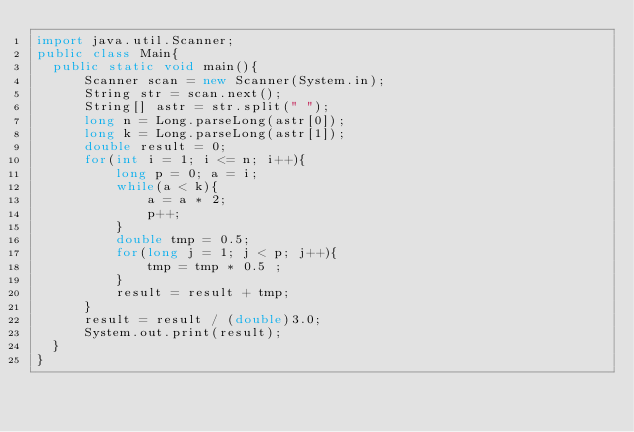Convert code to text. <code><loc_0><loc_0><loc_500><loc_500><_Java_>import java.util.Scanner;
public class Main{
  public static void main(){
      Scanner scan = new Scanner(System.in);
      String str = scan.next();
      String[] astr = str.split(" ");
      long n = Long.parseLong(astr[0]);
      long k = Long.parseLong(astr[1]);
      double result = 0;
      for(int i = 1; i <= n; i++){
          long p = 0; a = i;	
          while(a < k){
              a = a * 2;
              p++;
          }
          double tmp = 0.5;
          for(long j = 1; j < p; j++){
              tmp = tmp * 0.5 ;
          }
          result = result + tmp;
      }
      result = result / (double)3.0;
      System.out.print(result);
  }
}
</code> 